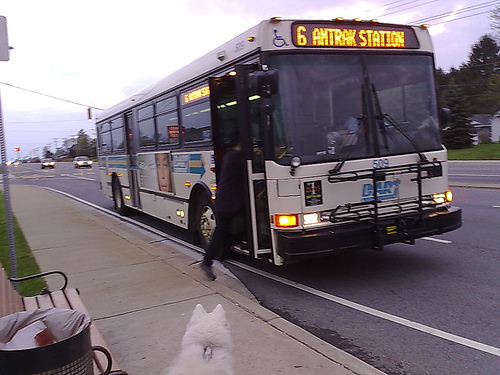Please provide the bounding box coordinate of the region this sentence describes: the wide windshield. The wide windshield, a crucial piece for driver visibility, spans from coordinates [0.54, 0.22, 0.89, 0.44], covering a significant portion of the front view. 